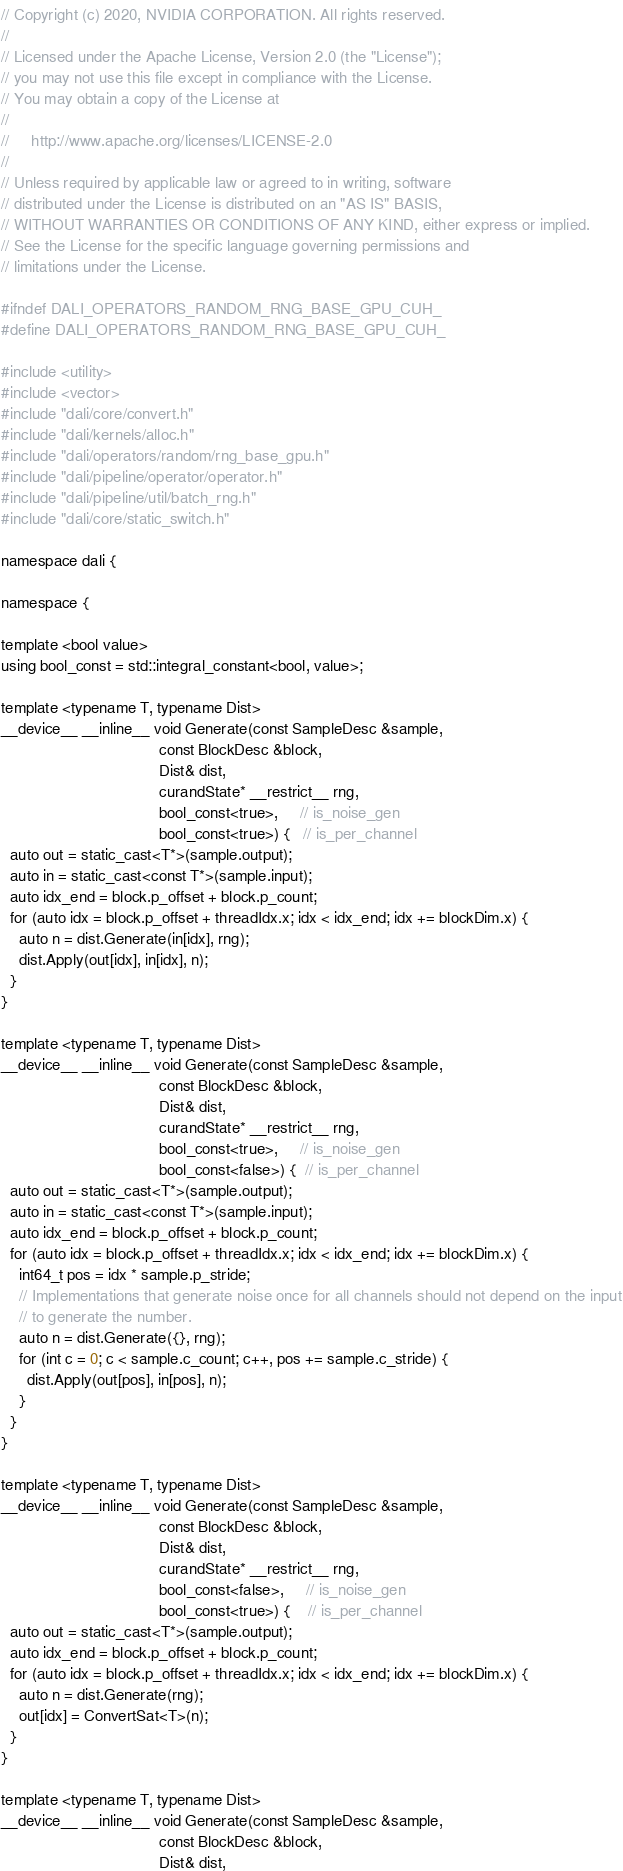<code> <loc_0><loc_0><loc_500><loc_500><_Cuda_>// Copyright (c) 2020, NVIDIA CORPORATION. All rights reserved.
//
// Licensed under the Apache License, Version 2.0 (the "License");
// you may not use this file except in compliance with the License.
// You may obtain a copy of the License at
//
//     http://www.apache.org/licenses/LICENSE-2.0
//
// Unless required by applicable law or agreed to in writing, software
// distributed under the License is distributed on an "AS IS" BASIS,
// WITHOUT WARRANTIES OR CONDITIONS OF ANY KIND, either express or implied.
// See the License for the specific language governing permissions and
// limitations under the License.

#ifndef DALI_OPERATORS_RANDOM_RNG_BASE_GPU_CUH_
#define DALI_OPERATORS_RANDOM_RNG_BASE_GPU_CUH_

#include <utility>
#include <vector>
#include "dali/core/convert.h"
#include "dali/kernels/alloc.h"
#include "dali/operators/random/rng_base_gpu.h"
#include "dali/pipeline/operator/operator.h"
#include "dali/pipeline/util/batch_rng.h"
#include "dali/core/static_switch.h"

namespace dali {

namespace {

template <bool value>
using bool_const = std::integral_constant<bool, value>;

template <typename T, typename Dist>
__device__ __inline__ void Generate(const SampleDesc &sample,
                                    const BlockDesc &block,
                                    Dist& dist,
                                    curandState* __restrict__ rng,
                                    bool_const<true>,     // is_noise_gen
                                    bool_const<true>) {   // is_per_channel
  auto out = static_cast<T*>(sample.output);
  auto in = static_cast<const T*>(sample.input);
  auto idx_end = block.p_offset + block.p_count;
  for (auto idx = block.p_offset + threadIdx.x; idx < idx_end; idx += blockDim.x) {
    auto n = dist.Generate(in[idx], rng);
    dist.Apply(out[idx], in[idx], n);
  }
}

template <typename T, typename Dist>
__device__ __inline__ void Generate(const SampleDesc &sample,
                                    const BlockDesc &block,
                                    Dist& dist,
                                    curandState* __restrict__ rng,
                                    bool_const<true>,     // is_noise_gen
                                    bool_const<false>) {  // is_per_channel
  auto out = static_cast<T*>(sample.output);
  auto in = static_cast<const T*>(sample.input);
  auto idx_end = block.p_offset + block.p_count;
  for (auto idx = block.p_offset + threadIdx.x; idx < idx_end; idx += blockDim.x) {
    int64_t pos = idx * sample.p_stride;
    // Implementations that generate noise once for all channels should not depend on the input
    // to generate the number.
    auto n = dist.Generate({}, rng);
    for (int c = 0; c < sample.c_count; c++, pos += sample.c_stride) {
      dist.Apply(out[pos], in[pos], n);
    }
  }
}

template <typename T, typename Dist>
__device__ __inline__ void Generate(const SampleDesc &sample,
                                    const BlockDesc &block,
                                    Dist& dist,
                                    curandState* __restrict__ rng,
                                    bool_const<false>,     // is_noise_gen
                                    bool_const<true>) {    // is_per_channel
  auto out = static_cast<T*>(sample.output);
  auto idx_end = block.p_offset + block.p_count;
  for (auto idx = block.p_offset + threadIdx.x; idx < idx_end; idx += blockDim.x) {
    auto n = dist.Generate(rng);
    out[idx] = ConvertSat<T>(n);
  }
}

template <typename T, typename Dist>
__device__ __inline__ void Generate(const SampleDesc &sample,
                                    const BlockDesc &block,
                                    Dist& dist,</code> 